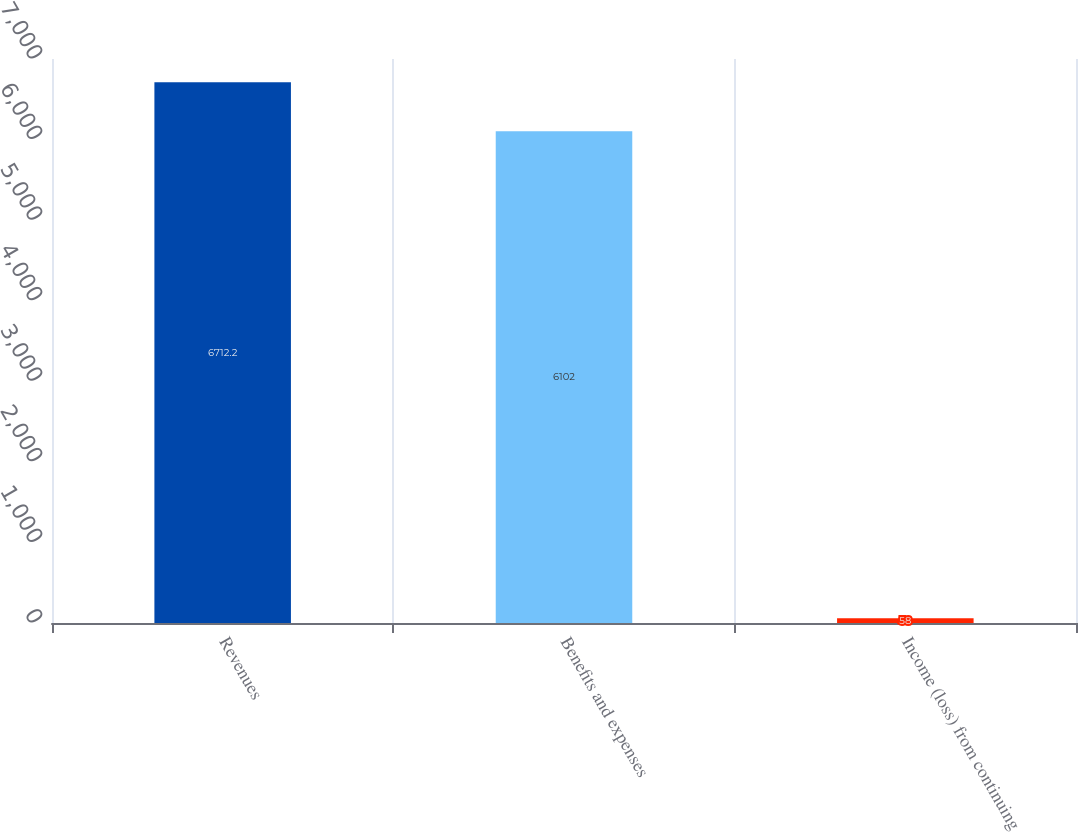Convert chart. <chart><loc_0><loc_0><loc_500><loc_500><bar_chart><fcel>Revenues<fcel>Benefits and expenses<fcel>Income (loss) from continuing<nl><fcel>6712.2<fcel>6102<fcel>58<nl></chart> 